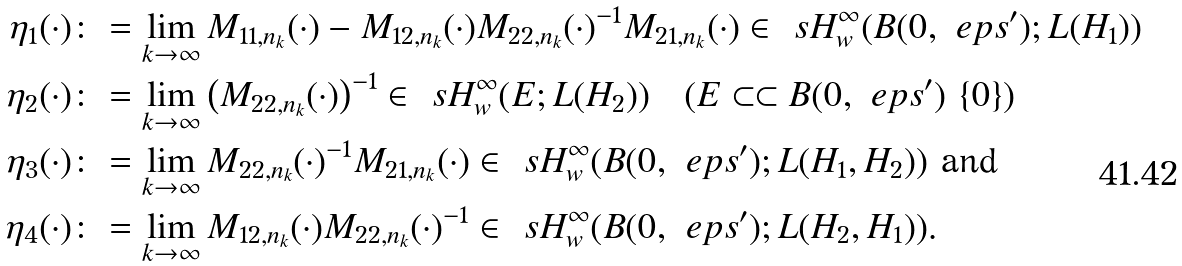Convert formula to latex. <formula><loc_0><loc_0><loc_500><loc_500>\eta _ { 1 } ( \cdot ) & \colon = \lim _ { k \to \infty } M _ { 1 1 , n _ { k } } ( \cdot ) - M _ { 1 2 , n _ { k } } ( \cdot ) M _ { 2 2 , n _ { k } } ( \cdot ) ^ { - 1 } M _ { 2 1 , n _ { k } } ( \cdot ) \in \ s H ^ { \infty } _ { w } ( B ( 0 , \ e p s ^ { \prime } ) ; L ( H _ { 1 } ) ) \\ \eta _ { 2 } ( \cdot ) & \colon = \lim _ { k \to \infty } \left ( M _ { 2 2 , n _ { k } } ( \cdot ) \right ) ^ { - 1 } \in \ s H ^ { \infty } _ { w } ( E ; L ( H _ { 2 } ) ) \quad ( E \subset \subset B ( 0 , \ e p s ^ { \prime } ) \ \{ 0 \} ) \\ \eta _ { 3 } ( \cdot ) & \colon = \lim _ { k \to \infty } M _ { 2 2 , n _ { k } } ( \cdot ) ^ { - 1 } M _ { 2 1 , n _ { k } } ( \cdot ) \in \ s H ^ { \infty } _ { w } ( B ( 0 , \ e p s ^ { \prime } ) ; L ( H _ { 1 } , H _ { 2 } ) ) \text { and } \\ \eta _ { 4 } ( \cdot ) & \colon = \lim _ { k \to \infty } M _ { 1 2 , n _ { k } } ( \cdot ) M _ { 2 2 , n _ { k } } ( \cdot ) ^ { - 1 } \in \ s H ^ { \infty } _ { w } ( B ( 0 , \ e p s ^ { \prime } ) ; L ( H _ { 2 } , H _ { 1 } ) ) .</formula> 